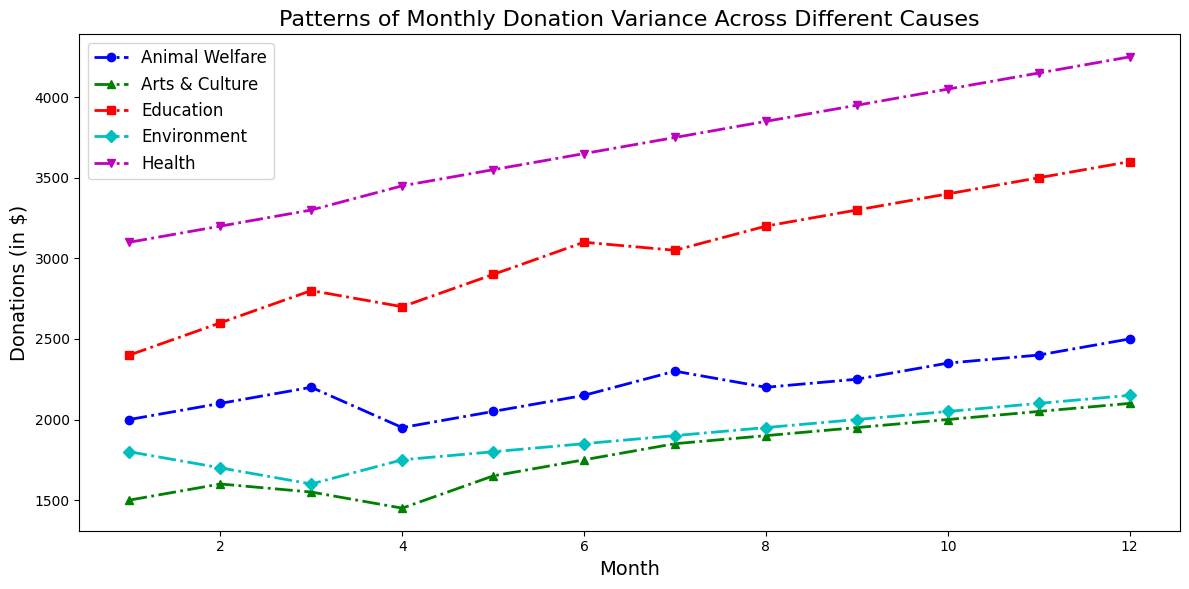What was the difference in donations between Health and Arts & Culture in December? To find the difference, look at the donations for both causes in December. Health received 4250 and Arts & Culture received 2100. Subtract 2100 from 4250 to find the difference.
Answer: 2150 How did Animal Welfare donations change from January to June? Look at the donations for Animal Welfare in January (2000) and June (2150). Find the difference by subtracting 2000 from 2150.
Answer: Increased by 150 Which cause had the highest variance in donations over the year? Visually inspect the fluctuation in donation lines over the months. Health donations show a consistent rise and larger numbers compared to other causes, indicating the highest variance.
Answer: Health What is the average monthly donation for Education? Add all the monthly donations for Education (2400, 2600, 2800, 2700, 2900, 3100, 3050, 3200, 3300, 3400, 3500, 3600) and divide by 12. The sum is 38550, and 38550 divided by 12 is 3212.5.
Answer: 3212.5 In which month did Environment receive the lowest donations, and what was the amount? Visually check the lowest point on the Environment donation line. The lowest donation was in March with 1600.
Answer: March, 1600 What was the total donation for Arts & Culture for the first half of the year? Sum the donations for Arts & Culture from January to June (1500, 1600, 1550, 1450, 1650, 1750). The total is 9500.
Answer: 9500 Which cause had a donation peak in July, and what was the amount? Determine the causes' donation amounts in July. Health had the highest donation peak in July with 3750.
Answer: Health, 3750 How did the donations for Environment compare in the second and first halves of the year? Sum donations for Environment from January to June (1800, 1700, 1600, 1750, 1800, 1850) and July to December (1900, 1950, 2000, 2050, 2100, 2150). The first half sum is 10500, and the second half sum is 12150. Subtract the first half sum from the second half sum to compare.
Answer: Increased by 1650 What is the average difference in donations between Health and Education? For each month, subtract the donations of Education from Health. Calculate the average of these differences. The differences are (700, 600, 500, 750, 650, 550, 700, 650, 650, 650, 650, 650). Average these by adding them (8700) and dividing by 12. The average difference is 725.
Answer: 725 Which cause maintained the most consistent donation levels throughout the year? Visually assess the donation lines' fluctuations. Education's line seems the most consistent, displaying relatively stable climbs without large fluctuations.
Answer: Education 